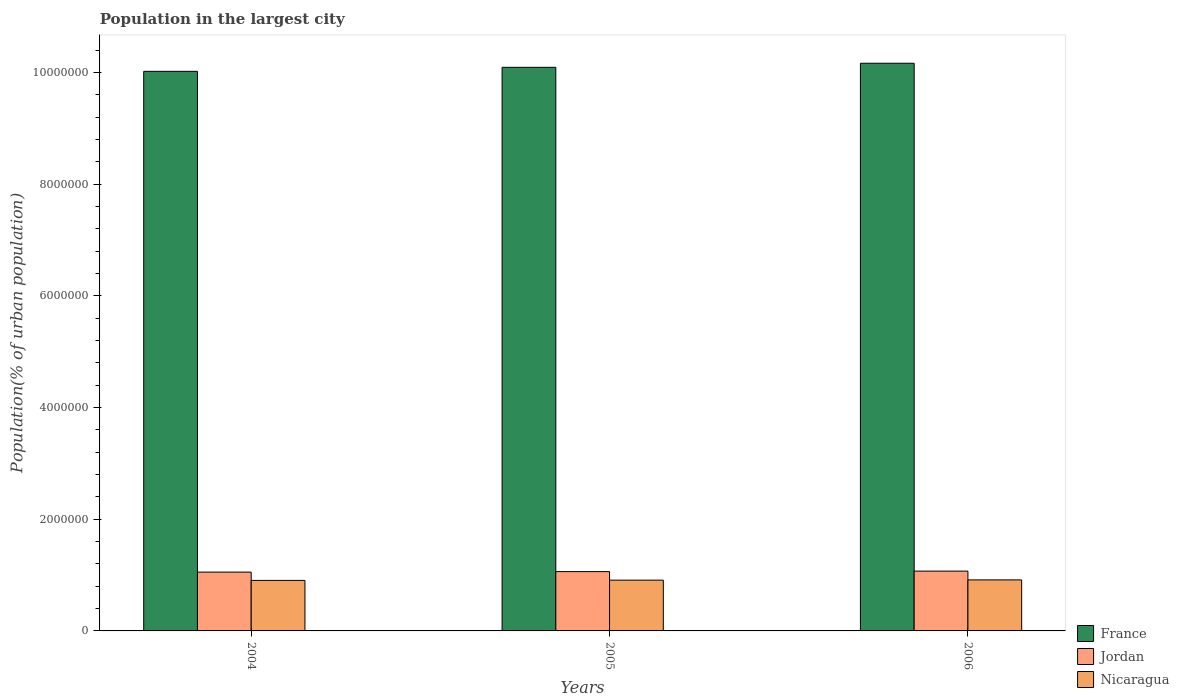How many groups of bars are there?
Your answer should be very brief. 3. Are the number of bars per tick equal to the number of legend labels?
Provide a short and direct response. Yes. What is the population in the largest city in Nicaragua in 2004?
Your answer should be compact. 9.05e+05. Across all years, what is the maximum population in the largest city in Jordan?
Keep it short and to the point. 1.07e+06. Across all years, what is the minimum population in the largest city in Nicaragua?
Your answer should be compact. 9.05e+05. In which year was the population in the largest city in France minimum?
Make the answer very short. 2004. What is the total population in the largest city in Nicaragua in the graph?
Ensure brevity in your answer.  2.73e+06. What is the difference between the population in the largest city in Jordan in 2005 and that in 2006?
Your response must be concise. -9191. What is the difference between the population in the largest city in Nicaragua in 2006 and the population in the largest city in France in 2004?
Give a very brief answer. -9.11e+06. What is the average population in the largest city in Jordan per year?
Provide a succinct answer. 1.06e+06. In the year 2006, what is the difference between the population in the largest city in Jordan and population in the largest city in France?
Offer a very short reply. -9.09e+06. What is the ratio of the population in the largest city in Jordan in 2005 to that in 2006?
Ensure brevity in your answer.  0.99. Is the population in the largest city in Jordan in 2004 less than that in 2005?
Keep it short and to the point. Yes. Is the difference between the population in the largest city in Jordan in 2005 and 2006 greater than the difference between the population in the largest city in France in 2005 and 2006?
Your answer should be very brief. Yes. What is the difference between the highest and the second highest population in the largest city in Nicaragua?
Keep it short and to the point. 4530. What is the difference between the highest and the lowest population in the largest city in Jordan?
Keep it short and to the point. 1.83e+04. What does the 3rd bar from the left in 2005 represents?
Give a very brief answer. Nicaragua. What does the 2nd bar from the right in 2006 represents?
Offer a terse response. Jordan. How many bars are there?
Make the answer very short. 9. Are all the bars in the graph horizontal?
Offer a terse response. No. What is the difference between two consecutive major ticks on the Y-axis?
Give a very brief answer. 2.00e+06. Are the values on the major ticks of Y-axis written in scientific E-notation?
Offer a very short reply. No. Does the graph contain any zero values?
Your answer should be very brief. No. Does the graph contain grids?
Provide a succinct answer. No. What is the title of the graph?
Your answer should be very brief. Population in the largest city. Does "Libya" appear as one of the legend labels in the graph?
Your response must be concise. No. What is the label or title of the X-axis?
Your answer should be very brief. Years. What is the label or title of the Y-axis?
Your answer should be very brief. Population(% of urban population). What is the Population(% of urban population) of France in 2004?
Provide a short and direct response. 1.00e+07. What is the Population(% of urban population) in Jordan in 2004?
Your answer should be compact. 1.05e+06. What is the Population(% of urban population) in Nicaragua in 2004?
Provide a short and direct response. 9.05e+05. What is the Population(% of urban population) of France in 2005?
Provide a short and direct response. 1.01e+07. What is the Population(% of urban population) of Jordan in 2005?
Keep it short and to the point. 1.06e+06. What is the Population(% of urban population) of Nicaragua in 2005?
Your answer should be very brief. 9.09e+05. What is the Population(% of urban population) in France in 2006?
Offer a terse response. 1.02e+07. What is the Population(% of urban population) of Jordan in 2006?
Offer a very short reply. 1.07e+06. What is the Population(% of urban population) in Nicaragua in 2006?
Offer a terse response. 9.14e+05. Across all years, what is the maximum Population(% of urban population) of France?
Your answer should be very brief. 1.02e+07. Across all years, what is the maximum Population(% of urban population) in Jordan?
Make the answer very short. 1.07e+06. Across all years, what is the maximum Population(% of urban population) of Nicaragua?
Provide a short and direct response. 9.14e+05. Across all years, what is the minimum Population(% of urban population) of France?
Provide a short and direct response. 1.00e+07. Across all years, what is the minimum Population(% of urban population) in Jordan?
Your response must be concise. 1.05e+06. Across all years, what is the minimum Population(% of urban population) of Nicaragua?
Your response must be concise. 9.05e+05. What is the total Population(% of urban population) of France in the graph?
Your answer should be compact. 3.03e+07. What is the total Population(% of urban population) in Jordan in the graph?
Provide a succinct answer. 3.19e+06. What is the total Population(% of urban population) of Nicaragua in the graph?
Provide a short and direct response. 2.73e+06. What is the difference between the Population(% of urban population) of France in 2004 and that in 2005?
Your answer should be compact. -7.20e+04. What is the difference between the Population(% of urban population) in Jordan in 2004 and that in 2005?
Make the answer very short. -9112. What is the difference between the Population(% of urban population) of Nicaragua in 2004 and that in 2005?
Your answer should be compact. -4508. What is the difference between the Population(% of urban population) in France in 2004 and that in 2006?
Make the answer very short. -1.45e+05. What is the difference between the Population(% of urban population) of Jordan in 2004 and that in 2006?
Your answer should be compact. -1.83e+04. What is the difference between the Population(% of urban population) in Nicaragua in 2004 and that in 2006?
Make the answer very short. -9038. What is the difference between the Population(% of urban population) of France in 2005 and that in 2006?
Give a very brief answer. -7.26e+04. What is the difference between the Population(% of urban population) of Jordan in 2005 and that in 2006?
Provide a succinct answer. -9191. What is the difference between the Population(% of urban population) of Nicaragua in 2005 and that in 2006?
Make the answer very short. -4530. What is the difference between the Population(% of urban population) of France in 2004 and the Population(% of urban population) of Jordan in 2005?
Make the answer very short. 8.96e+06. What is the difference between the Population(% of urban population) in France in 2004 and the Population(% of urban population) in Nicaragua in 2005?
Your answer should be compact. 9.11e+06. What is the difference between the Population(% of urban population) in Jordan in 2004 and the Population(% of urban population) in Nicaragua in 2005?
Provide a short and direct response. 1.44e+05. What is the difference between the Population(% of urban population) in France in 2004 and the Population(% of urban population) in Jordan in 2006?
Give a very brief answer. 8.95e+06. What is the difference between the Population(% of urban population) in France in 2004 and the Population(% of urban population) in Nicaragua in 2006?
Your response must be concise. 9.11e+06. What is the difference between the Population(% of urban population) in Jordan in 2004 and the Population(% of urban population) in Nicaragua in 2006?
Your answer should be very brief. 1.39e+05. What is the difference between the Population(% of urban population) in France in 2005 and the Population(% of urban population) in Jordan in 2006?
Keep it short and to the point. 9.02e+06. What is the difference between the Population(% of urban population) in France in 2005 and the Population(% of urban population) in Nicaragua in 2006?
Give a very brief answer. 9.18e+06. What is the difference between the Population(% of urban population) in Jordan in 2005 and the Population(% of urban population) in Nicaragua in 2006?
Your response must be concise. 1.48e+05. What is the average Population(% of urban population) in France per year?
Offer a very short reply. 1.01e+07. What is the average Population(% of urban population) of Jordan per year?
Ensure brevity in your answer.  1.06e+06. What is the average Population(% of urban population) of Nicaragua per year?
Your response must be concise. 9.09e+05. In the year 2004, what is the difference between the Population(% of urban population) in France and Population(% of urban population) in Jordan?
Ensure brevity in your answer.  8.97e+06. In the year 2004, what is the difference between the Population(% of urban population) in France and Population(% of urban population) in Nicaragua?
Your answer should be very brief. 9.12e+06. In the year 2004, what is the difference between the Population(% of urban population) of Jordan and Population(% of urban population) of Nicaragua?
Ensure brevity in your answer.  1.48e+05. In the year 2005, what is the difference between the Population(% of urban population) of France and Population(% of urban population) of Jordan?
Your answer should be compact. 9.03e+06. In the year 2005, what is the difference between the Population(% of urban population) in France and Population(% of urban population) in Nicaragua?
Offer a very short reply. 9.18e+06. In the year 2005, what is the difference between the Population(% of urban population) of Jordan and Population(% of urban population) of Nicaragua?
Offer a terse response. 1.53e+05. In the year 2006, what is the difference between the Population(% of urban population) in France and Population(% of urban population) in Jordan?
Offer a terse response. 9.09e+06. In the year 2006, what is the difference between the Population(% of urban population) of France and Population(% of urban population) of Nicaragua?
Your response must be concise. 9.25e+06. In the year 2006, what is the difference between the Population(% of urban population) of Jordan and Population(% of urban population) of Nicaragua?
Your answer should be very brief. 1.58e+05. What is the ratio of the Population(% of urban population) of France in 2004 to that in 2005?
Provide a succinct answer. 0.99. What is the ratio of the Population(% of urban population) in France in 2004 to that in 2006?
Offer a very short reply. 0.99. What is the ratio of the Population(% of urban population) in Jordan in 2004 to that in 2006?
Make the answer very short. 0.98. What is the ratio of the Population(% of urban population) of Jordan in 2005 to that in 2006?
Ensure brevity in your answer.  0.99. What is the ratio of the Population(% of urban population) of Nicaragua in 2005 to that in 2006?
Your answer should be very brief. 0.99. What is the difference between the highest and the second highest Population(% of urban population) in France?
Keep it short and to the point. 7.26e+04. What is the difference between the highest and the second highest Population(% of urban population) of Jordan?
Give a very brief answer. 9191. What is the difference between the highest and the second highest Population(% of urban population) of Nicaragua?
Keep it short and to the point. 4530. What is the difference between the highest and the lowest Population(% of urban population) in France?
Give a very brief answer. 1.45e+05. What is the difference between the highest and the lowest Population(% of urban population) of Jordan?
Offer a terse response. 1.83e+04. What is the difference between the highest and the lowest Population(% of urban population) in Nicaragua?
Your answer should be very brief. 9038. 